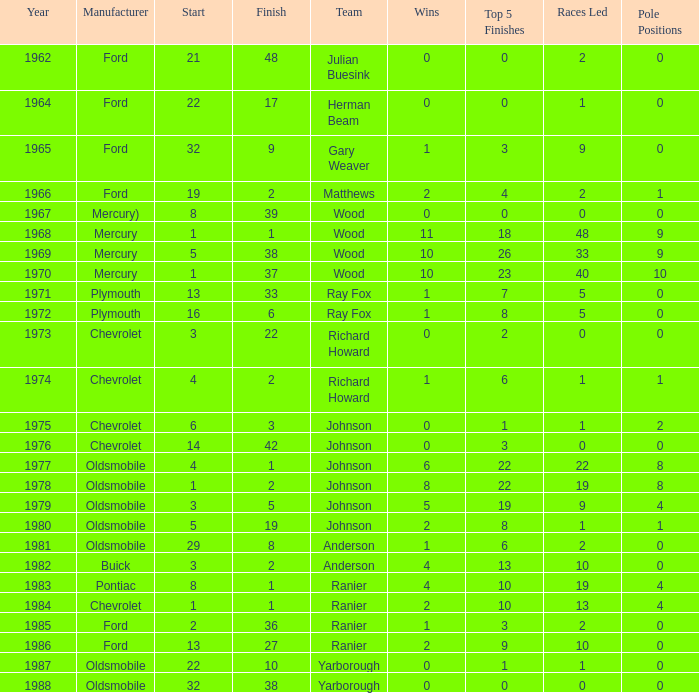What is the smallest finish time for a race where start was less than 3, buick was the manufacturer, and the race was held after 1978? None. 